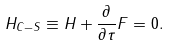<formula> <loc_0><loc_0><loc_500><loc_500>H _ { C - S } \equiv H + \frac { \partial } { \partial \tau } F = 0 .</formula> 